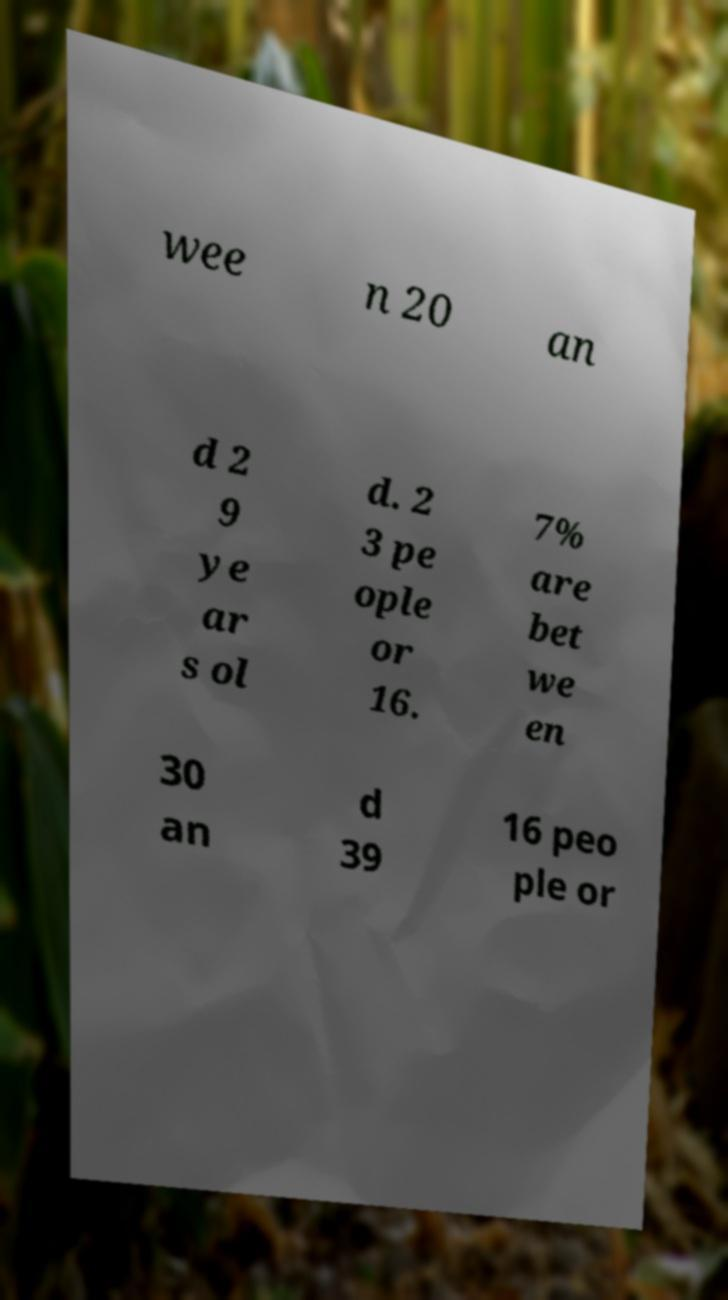For documentation purposes, I need the text within this image transcribed. Could you provide that? wee n 20 an d 2 9 ye ar s ol d. 2 3 pe ople or 16. 7% are bet we en 30 an d 39 16 peo ple or 